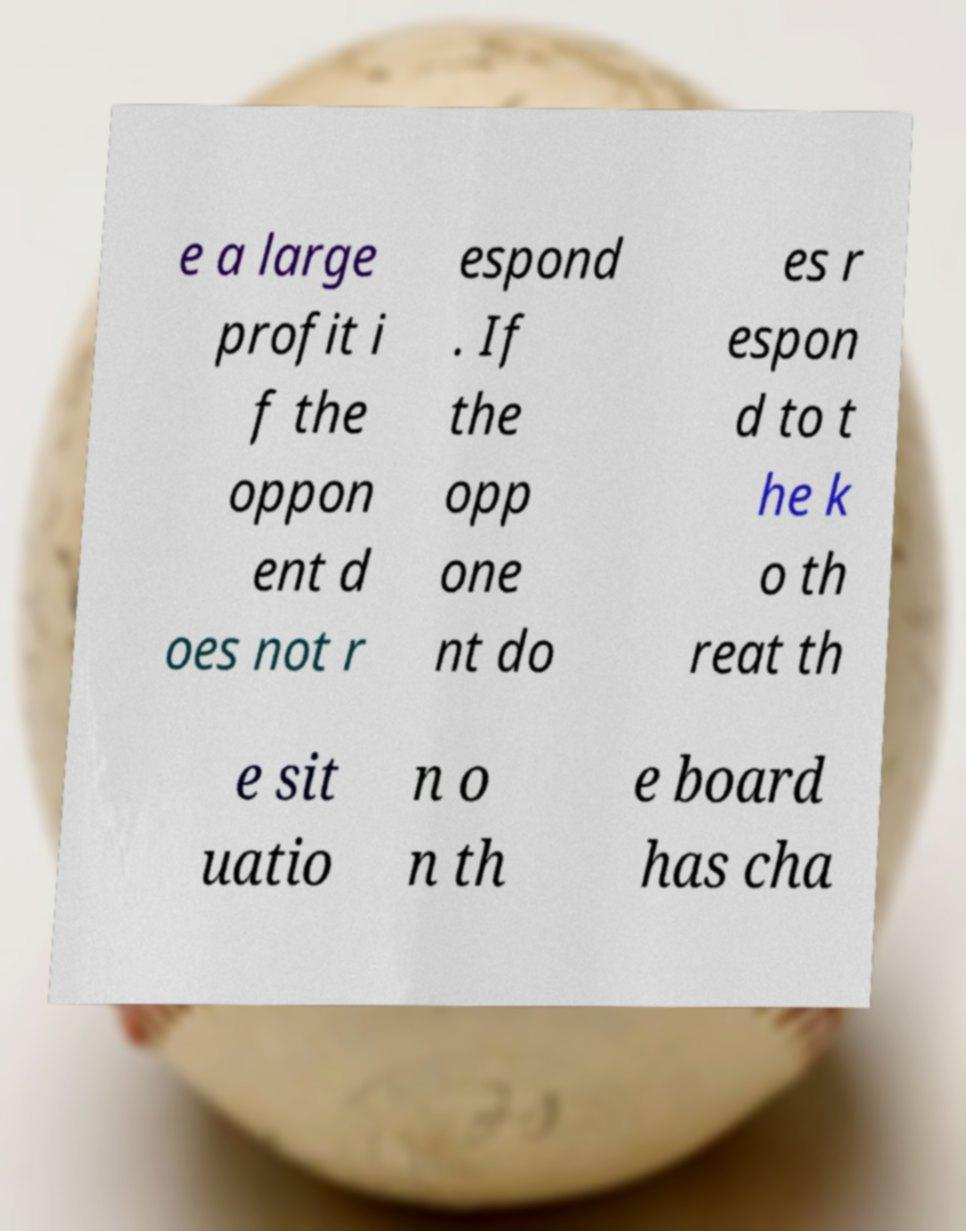What messages or text are displayed in this image? I need them in a readable, typed format. e a large profit i f the oppon ent d oes not r espond . If the opp one nt do es r espon d to t he k o th reat th e sit uatio n o n th e board has cha 